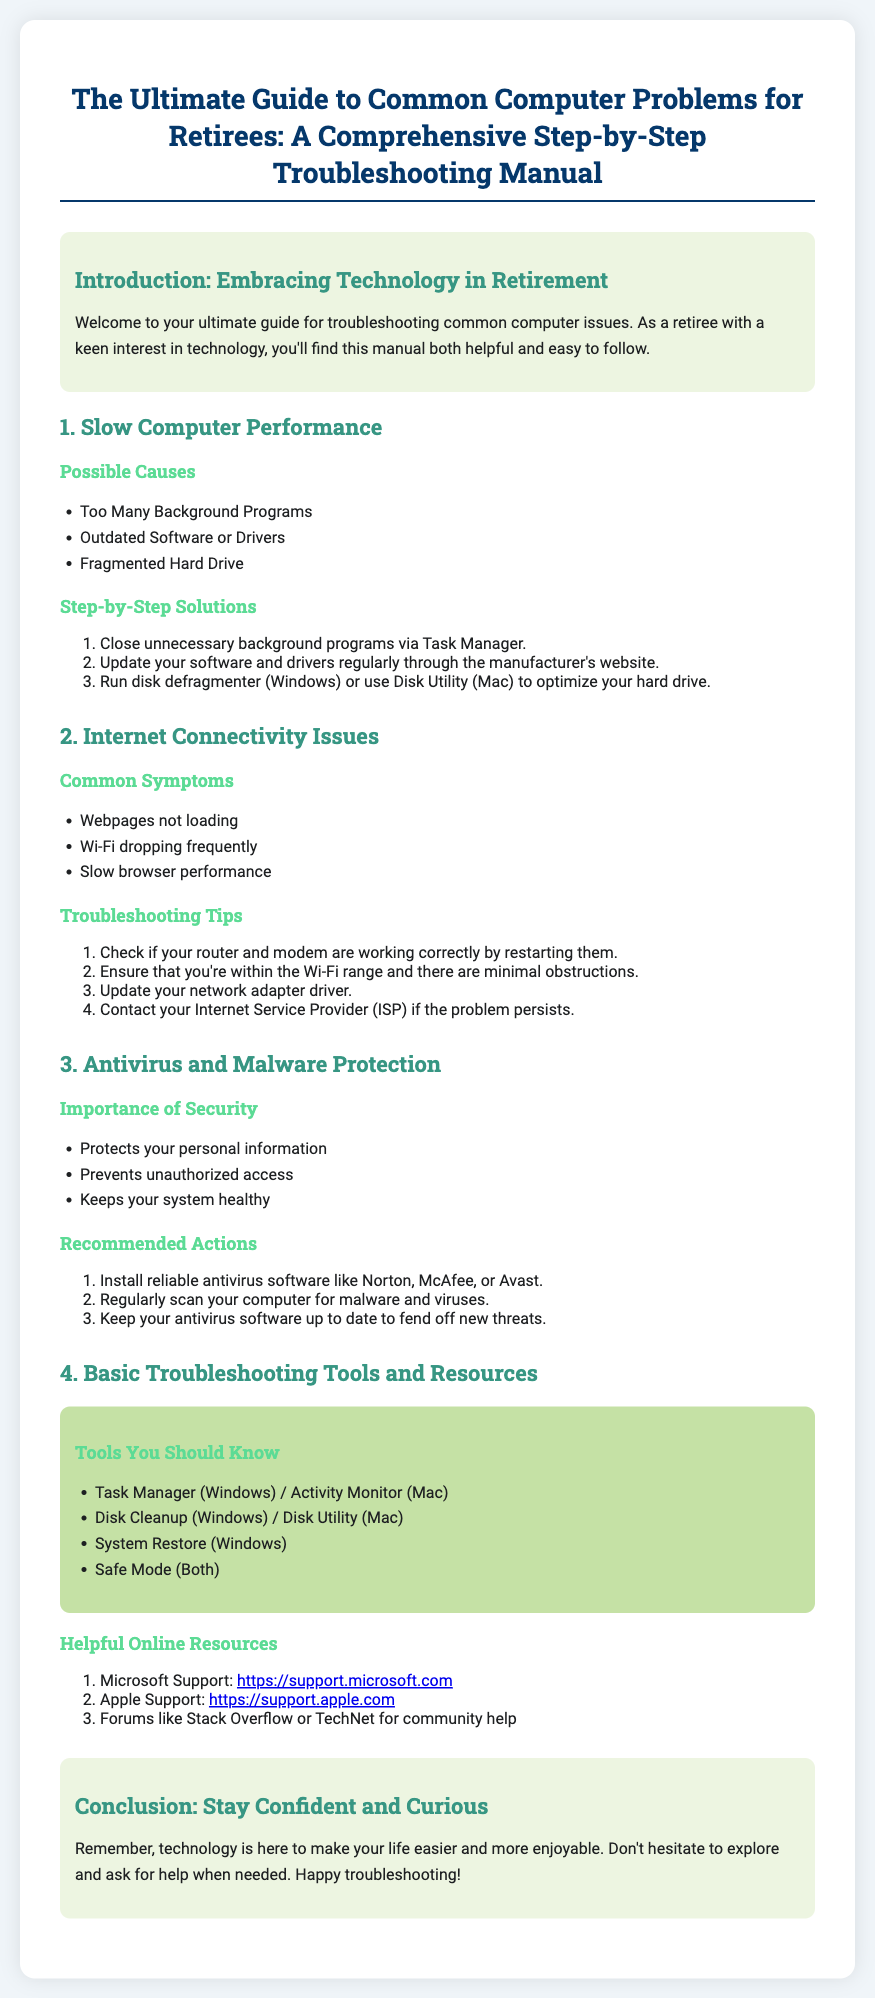What is the title of the guide? The title appears at the top of the document and outlines the main topic of the content.
Answer: The Ultimate Guide to Common Computer Problems for Retirees: A Comprehensive Step-by-Step Troubleshooting Manual What are two possible causes of slow computer performance? This information is listed under the section for slow computer performance, which discusses the reasons for the issue.
Answer: Too Many Background Programs, Outdated Software or Drivers What should you do to optimize your hard drive? This is detailed in the step-by-step solutions for slow computer performance, outlining a specific action to take.
Answer: Run disk defragmenter (Windows) or use Disk Utility (Mac) Which software is recommended for malware protection? This is found in the recommendations for antivirus and malware protection, pointing out suggested tools for retaining computer health.
Answer: Norton, McAfee, or Avast How many tools are listed in the Basic Troubleshooting Tools and Resources section? The number of tools mentioned gives a quick overview of what resources the manual covers for troubleshooting.
Answer: Four What is a common symptom of internet connectivity issues? This is mentioned in the list of common symptoms for internet-related problems, highlighting issues users may face.
Answer: Webpages not loading What does the conclusion encourage you to do? The conclusion emphasizes a supportive message about interacting with technology in a positive manner.
Answer: Explore and ask for help What is the background color of the introduction section? This can be determined from the visual design aspects specified in the document, highlighting a distinctive area.
Answer: Light green 